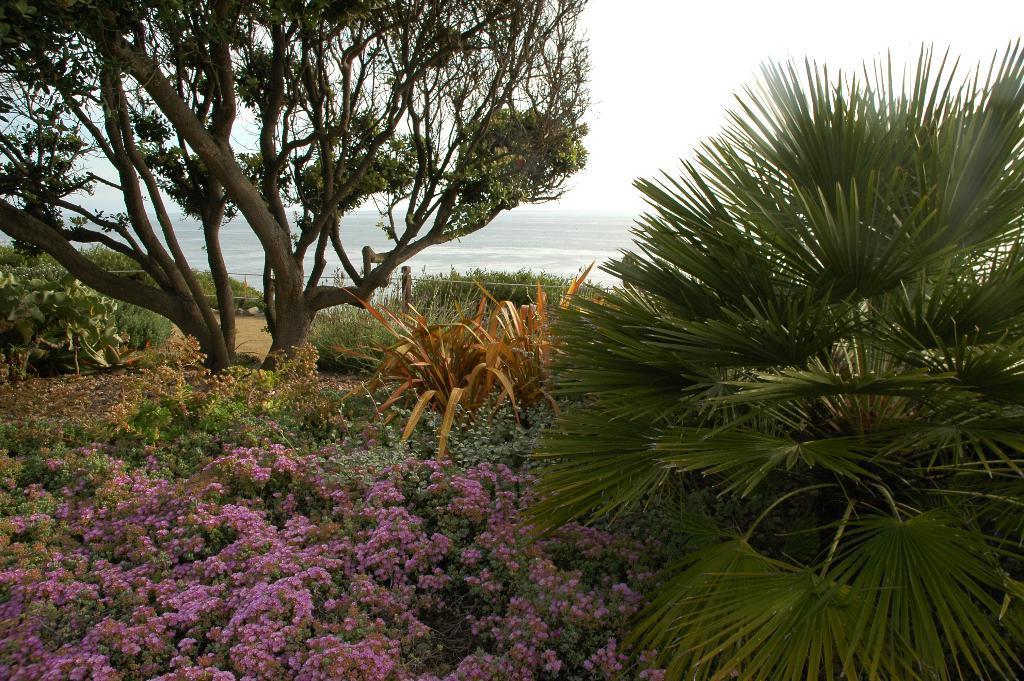How would you summarize this image in a sentence or two? This image is taken outdoors. In the background there is a sea with waves. At the bottom of the image there is a ground with many plants and a tree. There are a few flowers on the plant. 